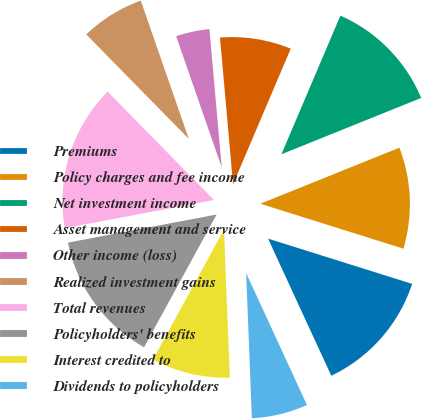Convert chart to OTSL. <chart><loc_0><loc_0><loc_500><loc_500><pie_chart><fcel>Premiums<fcel>Policy charges and fee income<fcel>Net investment income<fcel>Asset management and service<fcel>Other income (loss)<fcel>Realized investment gains<fcel>Total revenues<fcel>Policyholders' benefits<fcel>Interest credited to<fcel>Dividends to policyholders<nl><fcel>13.28%<fcel>10.94%<fcel>12.5%<fcel>7.81%<fcel>3.91%<fcel>7.03%<fcel>15.62%<fcel>14.06%<fcel>8.59%<fcel>6.25%<nl></chart> 